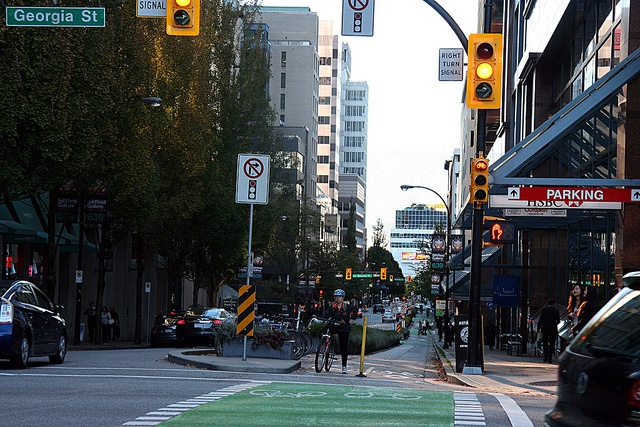Describe the objects in this image and their specific colors. I can see car in black, white, gray, and navy tones, car in black, navy, gray, and white tones, traffic light in black, orange, and red tones, potted plant in black, navy, darkblue, and gray tones, and people in black, gray, maroon, and darkgray tones in this image. 